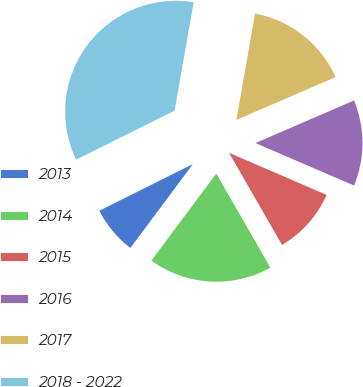Convert chart to OTSL. <chart><loc_0><loc_0><loc_500><loc_500><pie_chart><fcel>2013<fcel>2014<fcel>2015<fcel>2016<fcel>2017<fcel>2018 - 2022<nl><fcel>7.44%<fcel>18.51%<fcel>10.21%<fcel>12.97%<fcel>15.74%<fcel>35.13%<nl></chart> 